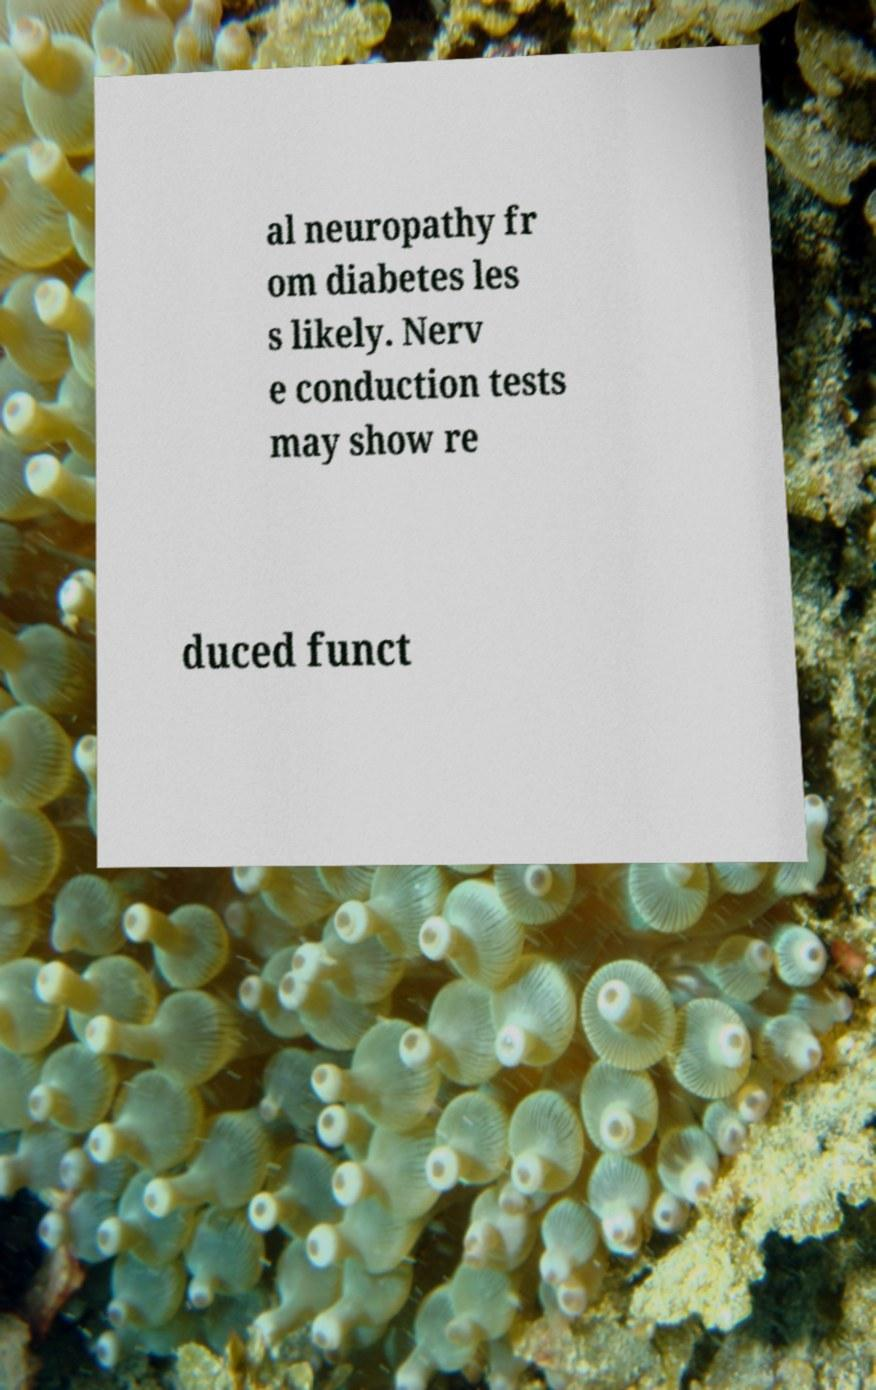I need the written content from this picture converted into text. Can you do that? al neuropathy fr om diabetes les s likely. Nerv e conduction tests may show re duced funct 